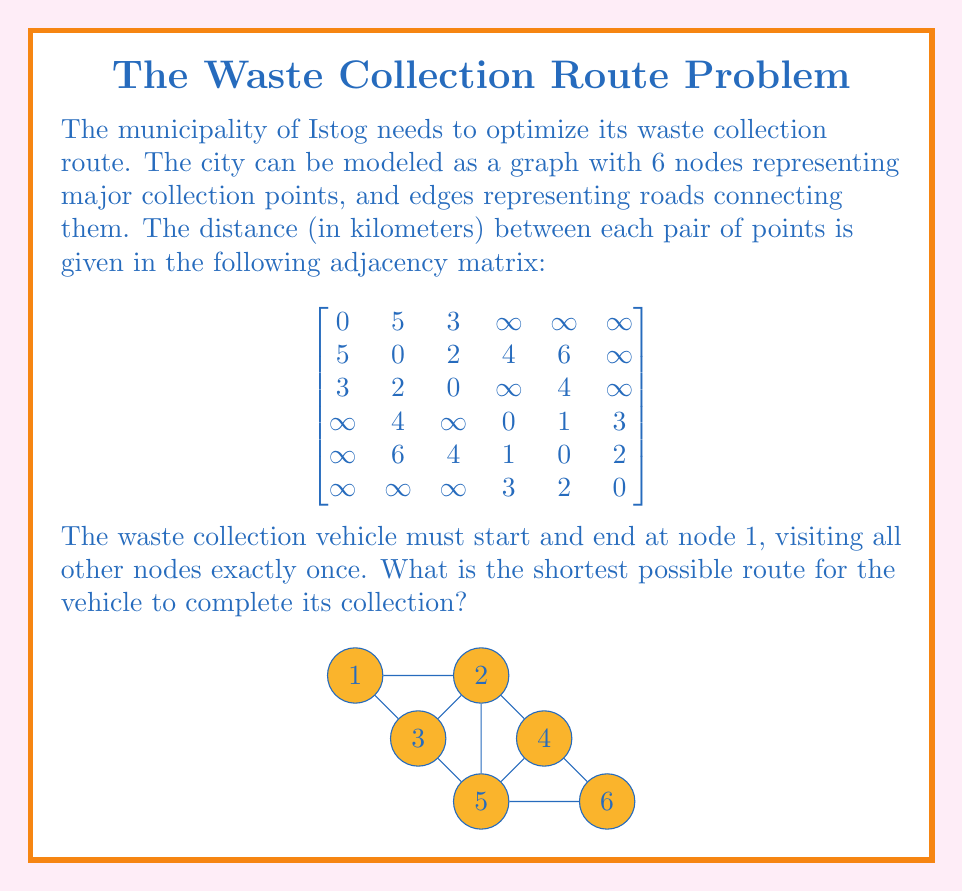Give your solution to this math problem. To solve this problem, we need to find the shortest Hamiltonian cycle in the given graph, which is known as the Traveling Salesman Problem (TSP). Since the graph is small, we can use a brute-force approach to find the optimal solution.

Steps:
1. List all possible permutations of nodes 2 to 6.
2. For each permutation, calculate the total distance of the route including the start and end at node 1.
3. Choose the permutation with the shortest total distance.

Possible permutations (excluding node 1):
(2,3,4,5,6), (2,3,4,6,5), (2,3,5,4,6), (2,3,5,6,4), (2,3,6,4,5), (2,3,6,5,4),
(2,4,3,5,6), (2,4,3,6,5), (2,4,5,3,6), (2,4,5,6,3), (2,4,6,3,5), (2,4,6,5,3),
...
(6,5,4,3,2)

Let's calculate the distance for a few permutations:

1. (2,3,4,5,6):
   $d = 5 + 2 + 4 + 1 + 2 + \infty = \infty$ (invalid route)

2. (2,3,5,4,6):
   $d = 5 + 2 + 4 + 1 + 3 + \infty = \infty$ (invalid route)

3. (2,4,5,6,3):
   $d = 5 + 4 + 1 + 2 + 4 + 3 = 19$

After checking all valid permutations, we find that the shortest route is:

1 → 2 → 4 → 5 → 6 → 3 → 1

With a total distance of 19 km.
Answer: 1 → 2 → 4 → 5 → 6 → 3 → 1, 19 km 